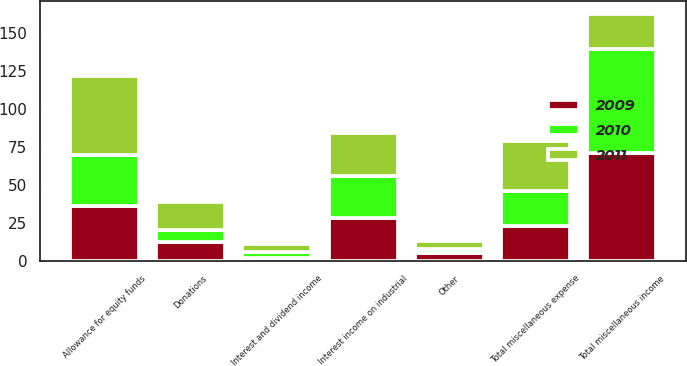<chart> <loc_0><loc_0><loc_500><loc_500><stacked_bar_chart><ecel><fcel>Interest and dividend income<fcel>Interest income on industrial<fcel>Allowance for equity funds<fcel>Other<fcel>Total miscellaneous income<fcel>Donations<fcel>Total miscellaneous expense<nl><fcel>2010<fcel>4<fcel>28<fcel>34<fcel>3<fcel>69<fcel>8<fcel>23<nl><fcel>2011<fcel>5<fcel>28<fcel>52<fcel>5<fcel>23<fcel>19<fcel>33<nl><fcel>2009<fcel>2<fcel>28<fcel>36<fcel>5<fcel>71<fcel>12<fcel>23<nl></chart> 